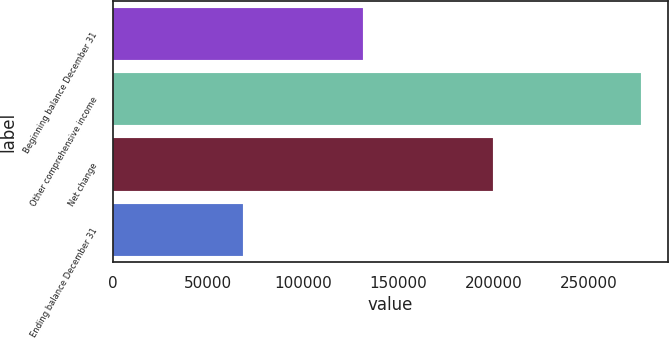Convert chart to OTSL. <chart><loc_0><loc_0><loc_500><loc_500><bar_chart><fcel>Beginning balance December 31<fcel>Other comprehensive income<fcel>Net change<fcel>Ending balance December 31<nl><fcel>131313<fcel>277703<fcel>199643<fcel>68330<nl></chart> 